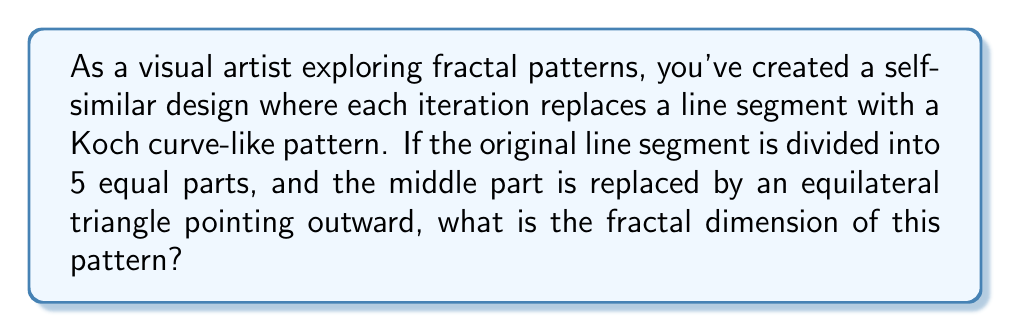What is the answer to this math problem? To calculate the fractal dimension of this self-similar pattern, we'll use the box-counting dimension formula:

$$ D = \frac{\log N}{\log(1/r)} $$

Where:
$D$ is the fractal dimension
$N$ is the number of self-similar pieces
$r$ is the scaling factor

Step 1: Determine $N$
In this pattern, each line segment is replaced by 5 smaller segments (4 straight lines and 1 triangular part). So, $N = 5$.

Step 2: Determine $r$
The scaling factor is the ratio of the length of each new segment to the original segment. Since the original line is divided into 5 equal parts, $r = 1/5$.

Step 3: Apply the formula
$$ D = \frac{\log N}{\log(1/r)} = \frac{\log 5}{\log 5} = 1.4649... $$

Step 4: Interpret the result
The fractal dimension lies between 1 (dimension of a line) and 2 (dimension of a plane), indicating that the pattern fills more space than a line but less than a plane.
Answer: $1.4649$ 